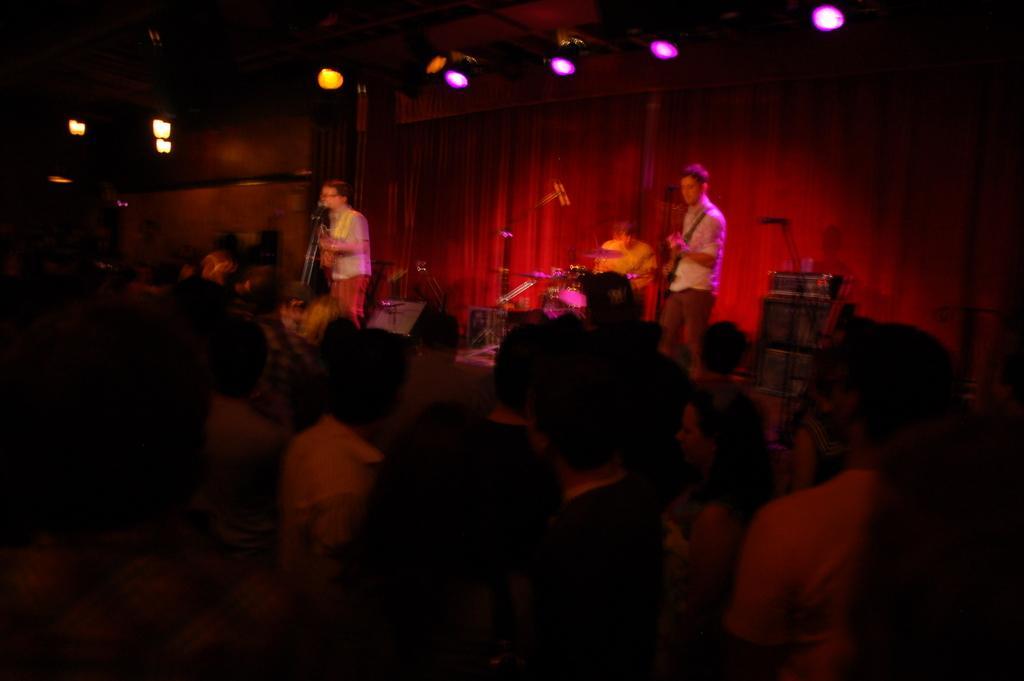In one or two sentences, can you explain what this image depicts? This image consists of two men playing guitars and standing on the dais. At the bottom, there is a crowd. In the background, there is a curtain along with the lights. 